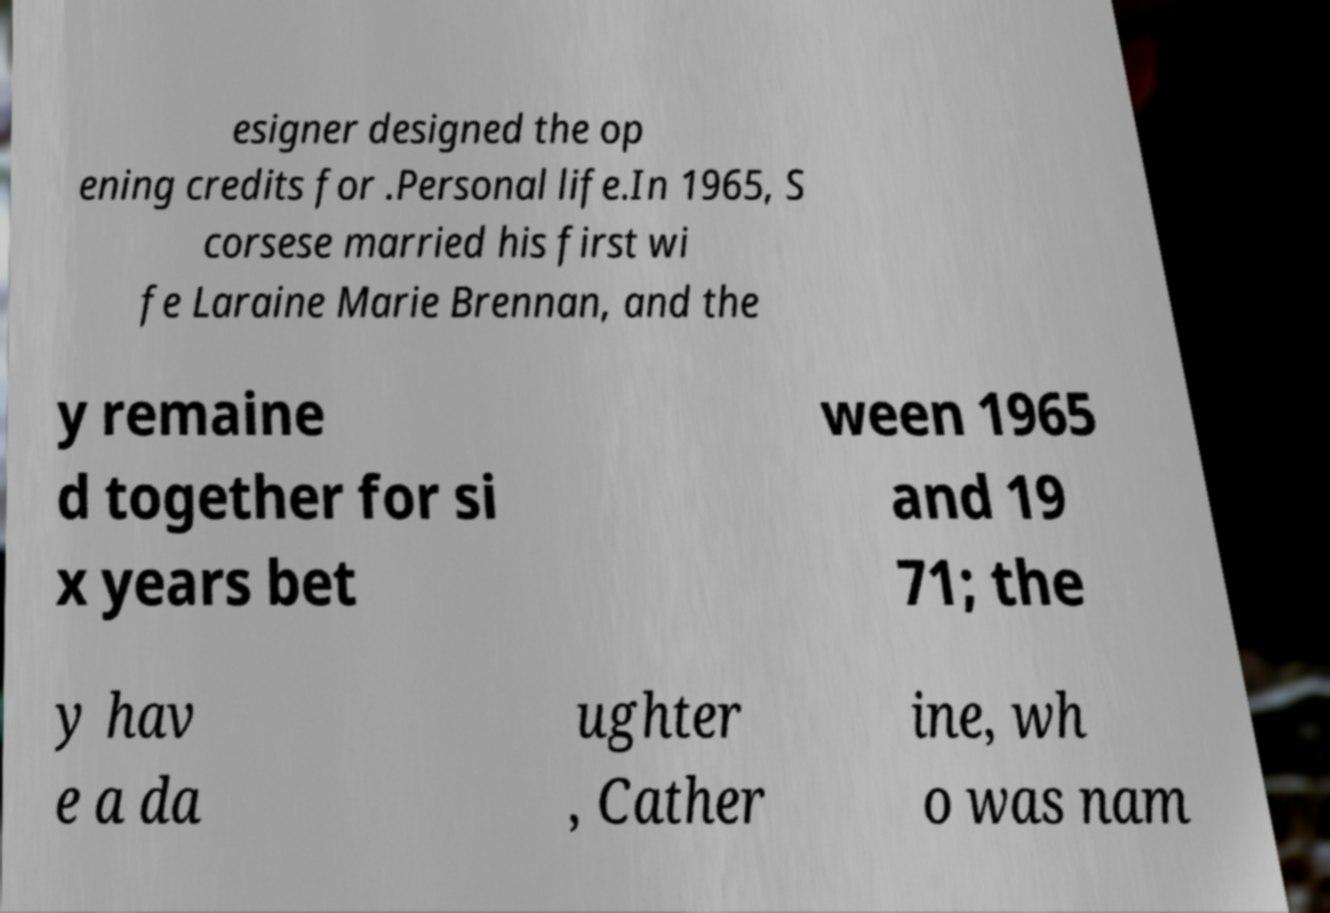There's text embedded in this image that I need extracted. Can you transcribe it verbatim? esigner designed the op ening credits for .Personal life.In 1965, S corsese married his first wi fe Laraine Marie Brennan, and the y remaine d together for si x years bet ween 1965 and 19 71; the y hav e a da ughter , Cather ine, wh o was nam 